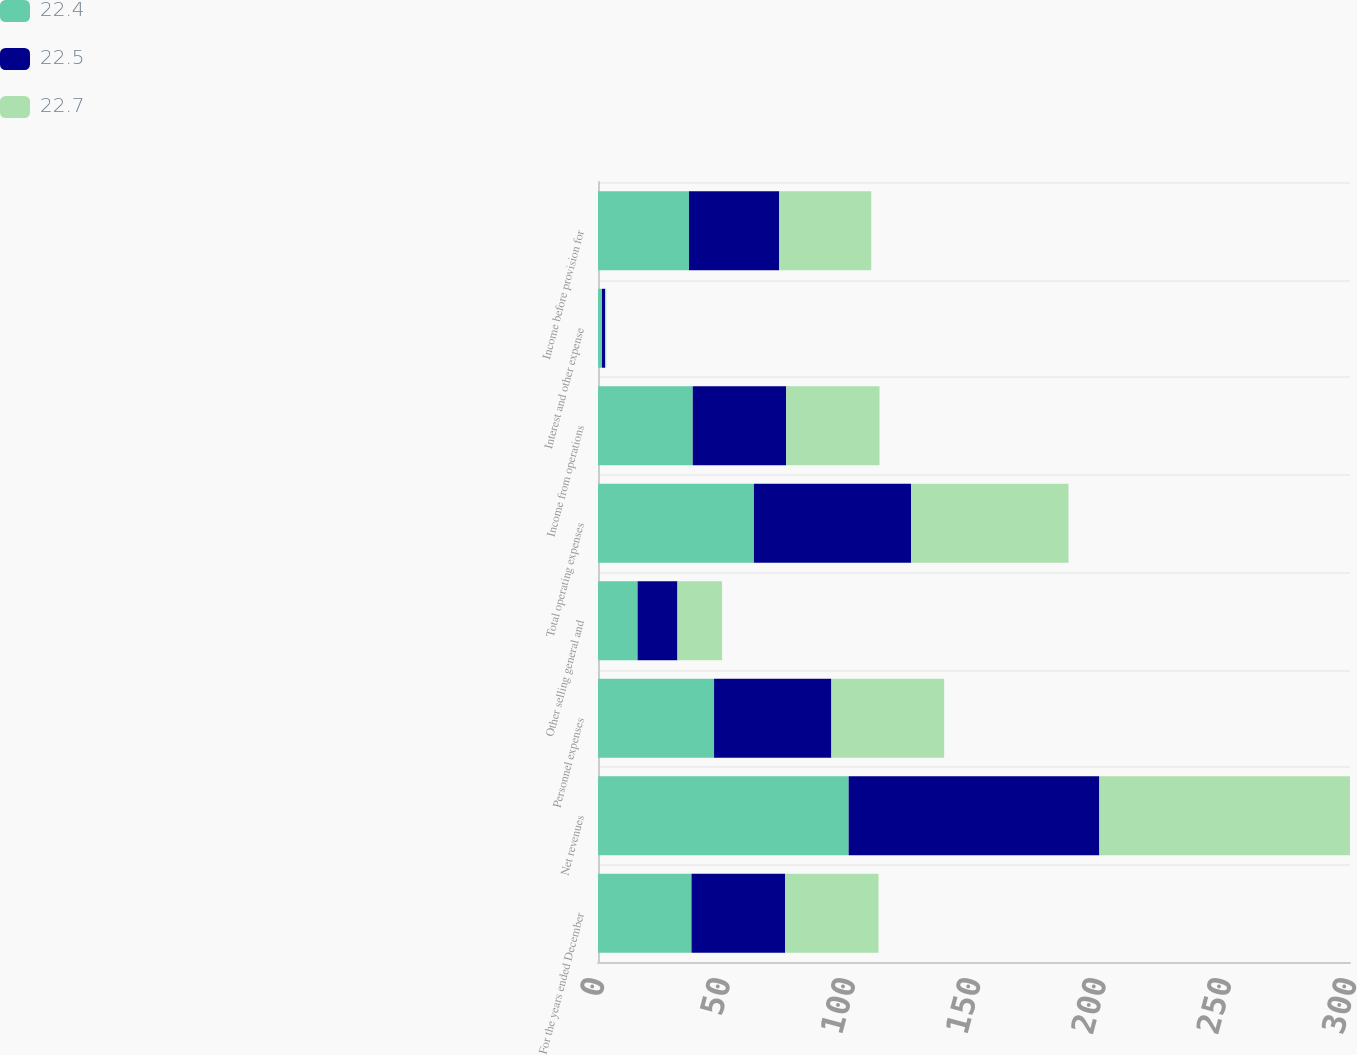<chart> <loc_0><loc_0><loc_500><loc_500><stacked_bar_chart><ecel><fcel>For the years ended December<fcel>Net revenues<fcel>Personnel expenses<fcel>Other selling general and<fcel>Total operating expenses<fcel>Income from operations<fcel>Interest and other expense<fcel>Income before provision for<nl><fcel>22.4<fcel>37.3<fcel>100<fcel>46.3<fcel>15.8<fcel>62.2<fcel>37.8<fcel>1.6<fcel>36.3<nl><fcel>22.5<fcel>37.3<fcel>100<fcel>46.8<fcel>15.9<fcel>62.7<fcel>37.3<fcel>1.2<fcel>36<nl><fcel>22.7<fcel>37.3<fcel>100<fcel>45<fcel>17.8<fcel>62.8<fcel>37.2<fcel>0.5<fcel>36.7<nl></chart> 